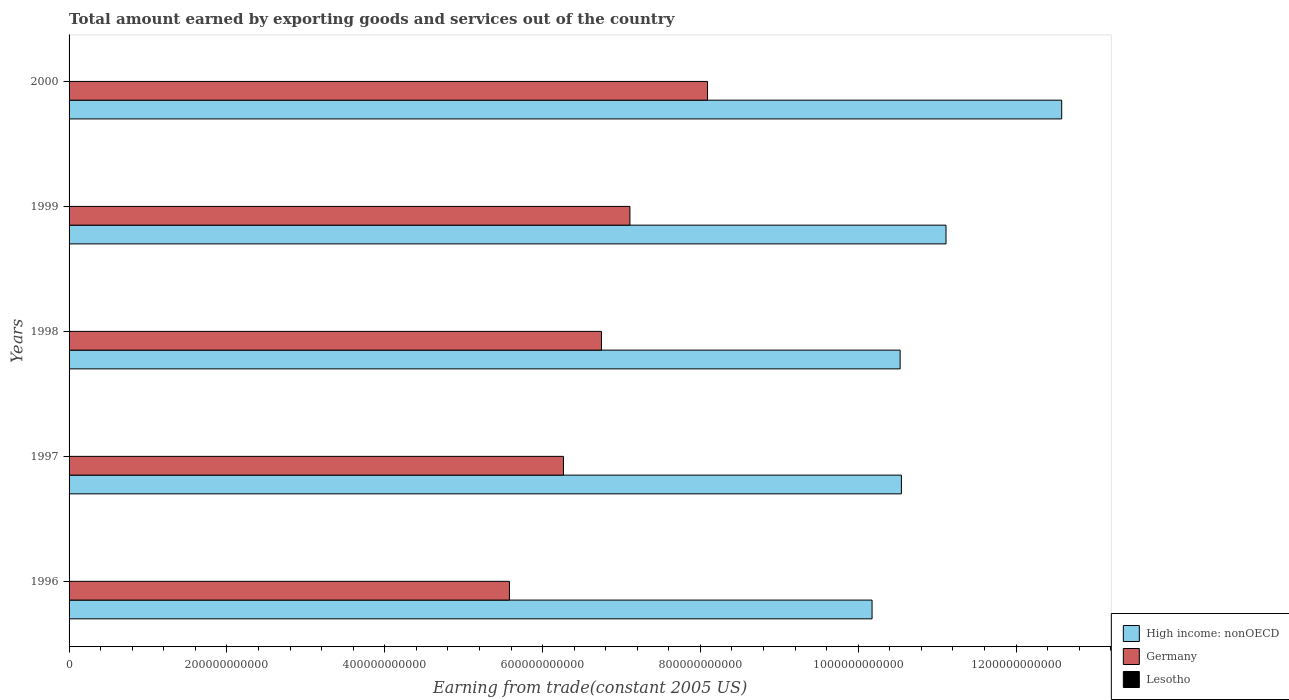How many different coloured bars are there?
Your answer should be compact. 3. How many groups of bars are there?
Offer a very short reply. 5. Are the number of bars per tick equal to the number of legend labels?
Make the answer very short. Yes. Are the number of bars on each tick of the Y-axis equal?
Your answer should be compact. Yes. How many bars are there on the 4th tick from the top?
Your answer should be compact. 3. How many bars are there on the 2nd tick from the bottom?
Your response must be concise. 3. What is the label of the 2nd group of bars from the top?
Your answer should be very brief. 1999. What is the total amount earned by exporting goods and services in High income: nonOECD in 1996?
Give a very brief answer. 1.02e+12. Across all years, what is the maximum total amount earned by exporting goods and services in High income: nonOECD?
Provide a short and direct response. 1.26e+12. Across all years, what is the minimum total amount earned by exporting goods and services in High income: nonOECD?
Ensure brevity in your answer.  1.02e+12. In which year was the total amount earned by exporting goods and services in Germany maximum?
Give a very brief answer. 2000. What is the total total amount earned by exporting goods and services in Lesotho in the graph?
Give a very brief answer. 1.39e+09. What is the difference between the total amount earned by exporting goods and services in High income: nonOECD in 1997 and that in 2000?
Keep it short and to the point. -2.03e+11. What is the difference between the total amount earned by exporting goods and services in Germany in 1997 and the total amount earned by exporting goods and services in Lesotho in 1999?
Offer a terse response. 6.26e+11. What is the average total amount earned by exporting goods and services in Germany per year?
Provide a succinct answer. 6.76e+11. In the year 1997, what is the difference between the total amount earned by exporting goods and services in High income: nonOECD and total amount earned by exporting goods and services in Germany?
Provide a short and direct response. 4.28e+11. What is the ratio of the total amount earned by exporting goods and services in Lesotho in 1996 to that in 2000?
Provide a short and direct response. 0.79. Is the difference between the total amount earned by exporting goods and services in High income: nonOECD in 1998 and 1999 greater than the difference between the total amount earned by exporting goods and services in Germany in 1998 and 1999?
Make the answer very short. No. What is the difference between the highest and the second highest total amount earned by exporting goods and services in High income: nonOECD?
Keep it short and to the point. 1.47e+11. What is the difference between the highest and the lowest total amount earned by exporting goods and services in Germany?
Ensure brevity in your answer.  2.51e+11. Is the sum of the total amount earned by exporting goods and services in Germany in 1998 and 2000 greater than the maximum total amount earned by exporting goods and services in High income: nonOECD across all years?
Keep it short and to the point. Yes. What does the 3rd bar from the top in 1997 represents?
Make the answer very short. High income: nonOECD. What does the 3rd bar from the bottom in 2000 represents?
Offer a very short reply. Lesotho. How many years are there in the graph?
Your response must be concise. 5. What is the difference between two consecutive major ticks on the X-axis?
Offer a terse response. 2.00e+11. Are the values on the major ticks of X-axis written in scientific E-notation?
Your answer should be compact. No. Does the graph contain any zero values?
Your answer should be compact. No. Where does the legend appear in the graph?
Your answer should be compact. Bottom right. How are the legend labels stacked?
Your response must be concise. Vertical. What is the title of the graph?
Offer a very short reply. Total amount earned by exporting goods and services out of the country. Does "Tajikistan" appear as one of the legend labels in the graph?
Your response must be concise. No. What is the label or title of the X-axis?
Provide a short and direct response. Earning from trade(constant 2005 US). What is the label or title of the Y-axis?
Offer a terse response. Years. What is the Earning from trade(constant 2005 US) of High income: nonOECD in 1996?
Offer a terse response. 1.02e+12. What is the Earning from trade(constant 2005 US) of Germany in 1996?
Provide a short and direct response. 5.58e+11. What is the Earning from trade(constant 2005 US) in Lesotho in 1996?
Your answer should be compact. 2.52e+08. What is the Earning from trade(constant 2005 US) in High income: nonOECD in 1997?
Offer a very short reply. 1.05e+12. What is the Earning from trade(constant 2005 US) of Germany in 1997?
Your response must be concise. 6.26e+11. What is the Earning from trade(constant 2005 US) of Lesotho in 1997?
Your answer should be very brief. 2.59e+08. What is the Earning from trade(constant 2005 US) of High income: nonOECD in 1998?
Your answer should be very brief. 1.05e+12. What is the Earning from trade(constant 2005 US) in Germany in 1998?
Keep it short and to the point. 6.75e+11. What is the Earning from trade(constant 2005 US) of Lesotho in 1998?
Provide a succinct answer. 3.01e+08. What is the Earning from trade(constant 2005 US) of High income: nonOECD in 1999?
Your response must be concise. 1.11e+12. What is the Earning from trade(constant 2005 US) in Germany in 1999?
Keep it short and to the point. 7.11e+11. What is the Earning from trade(constant 2005 US) in Lesotho in 1999?
Offer a very short reply. 2.60e+08. What is the Earning from trade(constant 2005 US) of High income: nonOECD in 2000?
Provide a succinct answer. 1.26e+12. What is the Earning from trade(constant 2005 US) of Germany in 2000?
Provide a succinct answer. 8.09e+11. What is the Earning from trade(constant 2005 US) of Lesotho in 2000?
Your response must be concise. 3.18e+08. Across all years, what is the maximum Earning from trade(constant 2005 US) in High income: nonOECD?
Your answer should be very brief. 1.26e+12. Across all years, what is the maximum Earning from trade(constant 2005 US) in Germany?
Your response must be concise. 8.09e+11. Across all years, what is the maximum Earning from trade(constant 2005 US) of Lesotho?
Offer a very short reply. 3.18e+08. Across all years, what is the minimum Earning from trade(constant 2005 US) of High income: nonOECD?
Your answer should be compact. 1.02e+12. Across all years, what is the minimum Earning from trade(constant 2005 US) of Germany?
Provide a short and direct response. 5.58e+11. Across all years, what is the minimum Earning from trade(constant 2005 US) of Lesotho?
Your answer should be very brief. 2.52e+08. What is the total Earning from trade(constant 2005 US) of High income: nonOECD in the graph?
Your answer should be very brief. 5.49e+12. What is the total Earning from trade(constant 2005 US) of Germany in the graph?
Offer a terse response. 3.38e+12. What is the total Earning from trade(constant 2005 US) in Lesotho in the graph?
Make the answer very short. 1.39e+09. What is the difference between the Earning from trade(constant 2005 US) in High income: nonOECD in 1996 and that in 1997?
Provide a short and direct response. -3.72e+1. What is the difference between the Earning from trade(constant 2005 US) in Germany in 1996 and that in 1997?
Keep it short and to the point. -6.85e+1. What is the difference between the Earning from trade(constant 2005 US) in Lesotho in 1996 and that in 1997?
Your answer should be very brief. -6.82e+06. What is the difference between the Earning from trade(constant 2005 US) in High income: nonOECD in 1996 and that in 1998?
Offer a very short reply. -3.56e+1. What is the difference between the Earning from trade(constant 2005 US) in Germany in 1996 and that in 1998?
Your answer should be compact. -1.17e+11. What is the difference between the Earning from trade(constant 2005 US) of Lesotho in 1996 and that in 1998?
Provide a succinct answer. -4.84e+07. What is the difference between the Earning from trade(constant 2005 US) of High income: nonOECD in 1996 and that in 1999?
Offer a very short reply. -9.37e+1. What is the difference between the Earning from trade(constant 2005 US) in Germany in 1996 and that in 1999?
Provide a short and direct response. -1.53e+11. What is the difference between the Earning from trade(constant 2005 US) of Lesotho in 1996 and that in 1999?
Keep it short and to the point. -7.43e+06. What is the difference between the Earning from trade(constant 2005 US) of High income: nonOECD in 1996 and that in 2000?
Provide a short and direct response. -2.40e+11. What is the difference between the Earning from trade(constant 2005 US) in Germany in 1996 and that in 2000?
Your answer should be very brief. -2.51e+11. What is the difference between the Earning from trade(constant 2005 US) of Lesotho in 1996 and that in 2000?
Provide a succinct answer. -6.55e+07. What is the difference between the Earning from trade(constant 2005 US) of High income: nonOECD in 1997 and that in 1998?
Keep it short and to the point. 1.61e+09. What is the difference between the Earning from trade(constant 2005 US) in Germany in 1997 and that in 1998?
Offer a terse response. -4.82e+1. What is the difference between the Earning from trade(constant 2005 US) of Lesotho in 1997 and that in 1998?
Make the answer very short. -4.16e+07. What is the difference between the Earning from trade(constant 2005 US) in High income: nonOECD in 1997 and that in 1999?
Provide a short and direct response. -5.65e+1. What is the difference between the Earning from trade(constant 2005 US) of Germany in 1997 and that in 1999?
Offer a terse response. -8.42e+1. What is the difference between the Earning from trade(constant 2005 US) of Lesotho in 1997 and that in 1999?
Ensure brevity in your answer.  -6.07e+05. What is the difference between the Earning from trade(constant 2005 US) of High income: nonOECD in 1997 and that in 2000?
Keep it short and to the point. -2.03e+11. What is the difference between the Earning from trade(constant 2005 US) of Germany in 1997 and that in 2000?
Your response must be concise. -1.83e+11. What is the difference between the Earning from trade(constant 2005 US) in Lesotho in 1997 and that in 2000?
Ensure brevity in your answer.  -5.87e+07. What is the difference between the Earning from trade(constant 2005 US) in High income: nonOECD in 1998 and that in 1999?
Offer a terse response. -5.81e+1. What is the difference between the Earning from trade(constant 2005 US) of Germany in 1998 and that in 1999?
Ensure brevity in your answer.  -3.61e+1. What is the difference between the Earning from trade(constant 2005 US) in Lesotho in 1998 and that in 1999?
Make the answer very short. 4.09e+07. What is the difference between the Earning from trade(constant 2005 US) of High income: nonOECD in 1998 and that in 2000?
Provide a short and direct response. -2.05e+11. What is the difference between the Earning from trade(constant 2005 US) of Germany in 1998 and that in 2000?
Offer a very short reply. -1.34e+11. What is the difference between the Earning from trade(constant 2005 US) of Lesotho in 1998 and that in 2000?
Offer a terse response. -1.72e+07. What is the difference between the Earning from trade(constant 2005 US) of High income: nonOECD in 1999 and that in 2000?
Offer a terse response. -1.47e+11. What is the difference between the Earning from trade(constant 2005 US) of Germany in 1999 and that in 2000?
Your answer should be very brief. -9.83e+1. What is the difference between the Earning from trade(constant 2005 US) in Lesotho in 1999 and that in 2000?
Provide a succinct answer. -5.81e+07. What is the difference between the Earning from trade(constant 2005 US) in High income: nonOECD in 1996 and the Earning from trade(constant 2005 US) in Germany in 1997?
Your answer should be compact. 3.91e+11. What is the difference between the Earning from trade(constant 2005 US) of High income: nonOECD in 1996 and the Earning from trade(constant 2005 US) of Lesotho in 1997?
Offer a terse response. 1.02e+12. What is the difference between the Earning from trade(constant 2005 US) of Germany in 1996 and the Earning from trade(constant 2005 US) of Lesotho in 1997?
Ensure brevity in your answer.  5.58e+11. What is the difference between the Earning from trade(constant 2005 US) of High income: nonOECD in 1996 and the Earning from trade(constant 2005 US) of Germany in 1998?
Keep it short and to the point. 3.43e+11. What is the difference between the Earning from trade(constant 2005 US) of High income: nonOECD in 1996 and the Earning from trade(constant 2005 US) of Lesotho in 1998?
Your answer should be very brief. 1.02e+12. What is the difference between the Earning from trade(constant 2005 US) in Germany in 1996 and the Earning from trade(constant 2005 US) in Lesotho in 1998?
Provide a short and direct response. 5.58e+11. What is the difference between the Earning from trade(constant 2005 US) of High income: nonOECD in 1996 and the Earning from trade(constant 2005 US) of Germany in 1999?
Offer a terse response. 3.07e+11. What is the difference between the Earning from trade(constant 2005 US) in High income: nonOECD in 1996 and the Earning from trade(constant 2005 US) in Lesotho in 1999?
Give a very brief answer. 1.02e+12. What is the difference between the Earning from trade(constant 2005 US) of Germany in 1996 and the Earning from trade(constant 2005 US) of Lesotho in 1999?
Provide a succinct answer. 5.58e+11. What is the difference between the Earning from trade(constant 2005 US) of High income: nonOECD in 1996 and the Earning from trade(constant 2005 US) of Germany in 2000?
Provide a short and direct response. 2.08e+11. What is the difference between the Earning from trade(constant 2005 US) of High income: nonOECD in 1996 and the Earning from trade(constant 2005 US) of Lesotho in 2000?
Your response must be concise. 1.02e+12. What is the difference between the Earning from trade(constant 2005 US) of Germany in 1996 and the Earning from trade(constant 2005 US) of Lesotho in 2000?
Your answer should be compact. 5.58e+11. What is the difference between the Earning from trade(constant 2005 US) in High income: nonOECD in 1997 and the Earning from trade(constant 2005 US) in Germany in 1998?
Offer a terse response. 3.80e+11. What is the difference between the Earning from trade(constant 2005 US) of High income: nonOECD in 1997 and the Earning from trade(constant 2005 US) of Lesotho in 1998?
Make the answer very short. 1.05e+12. What is the difference between the Earning from trade(constant 2005 US) of Germany in 1997 and the Earning from trade(constant 2005 US) of Lesotho in 1998?
Provide a short and direct response. 6.26e+11. What is the difference between the Earning from trade(constant 2005 US) of High income: nonOECD in 1997 and the Earning from trade(constant 2005 US) of Germany in 1999?
Make the answer very short. 3.44e+11. What is the difference between the Earning from trade(constant 2005 US) of High income: nonOECD in 1997 and the Earning from trade(constant 2005 US) of Lesotho in 1999?
Provide a short and direct response. 1.05e+12. What is the difference between the Earning from trade(constant 2005 US) of Germany in 1997 and the Earning from trade(constant 2005 US) of Lesotho in 1999?
Your response must be concise. 6.26e+11. What is the difference between the Earning from trade(constant 2005 US) of High income: nonOECD in 1997 and the Earning from trade(constant 2005 US) of Germany in 2000?
Ensure brevity in your answer.  2.46e+11. What is the difference between the Earning from trade(constant 2005 US) in High income: nonOECD in 1997 and the Earning from trade(constant 2005 US) in Lesotho in 2000?
Provide a short and direct response. 1.05e+12. What is the difference between the Earning from trade(constant 2005 US) in Germany in 1997 and the Earning from trade(constant 2005 US) in Lesotho in 2000?
Keep it short and to the point. 6.26e+11. What is the difference between the Earning from trade(constant 2005 US) in High income: nonOECD in 1998 and the Earning from trade(constant 2005 US) in Germany in 1999?
Your answer should be compact. 3.42e+11. What is the difference between the Earning from trade(constant 2005 US) in High income: nonOECD in 1998 and the Earning from trade(constant 2005 US) in Lesotho in 1999?
Make the answer very short. 1.05e+12. What is the difference between the Earning from trade(constant 2005 US) in Germany in 1998 and the Earning from trade(constant 2005 US) in Lesotho in 1999?
Provide a short and direct response. 6.74e+11. What is the difference between the Earning from trade(constant 2005 US) of High income: nonOECD in 1998 and the Earning from trade(constant 2005 US) of Germany in 2000?
Your answer should be very brief. 2.44e+11. What is the difference between the Earning from trade(constant 2005 US) of High income: nonOECD in 1998 and the Earning from trade(constant 2005 US) of Lesotho in 2000?
Your answer should be very brief. 1.05e+12. What is the difference between the Earning from trade(constant 2005 US) in Germany in 1998 and the Earning from trade(constant 2005 US) in Lesotho in 2000?
Offer a very short reply. 6.74e+11. What is the difference between the Earning from trade(constant 2005 US) in High income: nonOECD in 1999 and the Earning from trade(constant 2005 US) in Germany in 2000?
Make the answer very short. 3.02e+11. What is the difference between the Earning from trade(constant 2005 US) in High income: nonOECD in 1999 and the Earning from trade(constant 2005 US) in Lesotho in 2000?
Your answer should be very brief. 1.11e+12. What is the difference between the Earning from trade(constant 2005 US) of Germany in 1999 and the Earning from trade(constant 2005 US) of Lesotho in 2000?
Make the answer very short. 7.10e+11. What is the average Earning from trade(constant 2005 US) in High income: nonOECD per year?
Make the answer very short. 1.10e+12. What is the average Earning from trade(constant 2005 US) of Germany per year?
Your answer should be compact. 6.76e+11. What is the average Earning from trade(constant 2005 US) in Lesotho per year?
Make the answer very short. 2.78e+08. In the year 1996, what is the difference between the Earning from trade(constant 2005 US) in High income: nonOECD and Earning from trade(constant 2005 US) in Germany?
Keep it short and to the point. 4.59e+11. In the year 1996, what is the difference between the Earning from trade(constant 2005 US) in High income: nonOECD and Earning from trade(constant 2005 US) in Lesotho?
Offer a terse response. 1.02e+12. In the year 1996, what is the difference between the Earning from trade(constant 2005 US) in Germany and Earning from trade(constant 2005 US) in Lesotho?
Make the answer very short. 5.58e+11. In the year 1997, what is the difference between the Earning from trade(constant 2005 US) of High income: nonOECD and Earning from trade(constant 2005 US) of Germany?
Offer a terse response. 4.28e+11. In the year 1997, what is the difference between the Earning from trade(constant 2005 US) of High income: nonOECD and Earning from trade(constant 2005 US) of Lesotho?
Keep it short and to the point. 1.05e+12. In the year 1997, what is the difference between the Earning from trade(constant 2005 US) in Germany and Earning from trade(constant 2005 US) in Lesotho?
Your answer should be compact. 6.26e+11. In the year 1998, what is the difference between the Earning from trade(constant 2005 US) of High income: nonOECD and Earning from trade(constant 2005 US) of Germany?
Offer a very short reply. 3.78e+11. In the year 1998, what is the difference between the Earning from trade(constant 2005 US) of High income: nonOECD and Earning from trade(constant 2005 US) of Lesotho?
Keep it short and to the point. 1.05e+12. In the year 1998, what is the difference between the Earning from trade(constant 2005 US) of Germany and Earning from trade(constant 2005 US) of Lesotho?
Ensure brevity in your answer.  6.74e+11. In the year 1999, what is the difference between the Earning from trade(constant 2005 US) of High income: nonOECD and Earning from trade(constant 2005 US) of Germany?
Ensure brevity in your answer.  4.00e+11. In the year 1999, what is the difference between the Earning from trade(constant 2005 US) of High income: nonOECD and Earning from trade(constant 2005 US) of Lesotho?
Your answer should be very brief. 1.11e+12. In the year 1999, what is the difference between the Earning from trade(constant 2005 US) in Germany and Earning from trade(constant 2005 US) in Lesotho?
Offer a very short reply. 7.10e+11. In the year 2000, what is the difference between the Earning from trade(constant 2005 US) of High income: nonOECD and Earning from trade(constant 2005 US) of Germany?
Make the answer very short. 4.49e+11. In the year 2000, what is the difference between the Earning from trade(constant 2005 US) of High income: nonOECD and Earning from trade(constant 2005 US) of Lesotho?
Keep it short and to the point. 1.26e+12. In the year 2000, what is the difference between the Earning from trade(constant 2005 US) in Germany and Earning from trade(constant 2005 US) in Lesotho?
Offer a terse response. 8.09e+11. What is the ratio of the Earning from trade(constant 2005 US) in High income: nonOECD in 1996 to that in 1997?
Give a very brief answer. 0.96. What is the ratio of the Earning from trade(constant 2005 US) in Germany in 1996 to that in 1997?
Make the answer very short. 0.89. What is the ratio of the Earning from trade(constant 2005 US) in Lesotho in 1996 to that in 1997?
Offer a terse response. 0.97. What is the ratio of the Earning from trade(constant 2005 US) of High income: nonOECD in 1996 to that in 1998?
Your answer should be compact. 0.97. What is the ratio of the Earning from trade(constant 2005 US) in Germany in 1996 to that in 1998?
Offer a very short reply. 0.83. What is the ratio of the Earning from trade(constant 2005 US) of Lesotho in 1996 to that in 1998?
Give a very brief answer. 0.84. What is the ratio of the Earning from trade(constant 2005 US) of High income: nonOECD in 1996 to that in 1999?
Your answer should be compact. 0.92. What is the ratio of the Earning from trade(constant 2005 US) of Germany in 1996 to that in 1999?
Your response must be concise. 0.79. What is the ratio of the Earning from trade(constant 2005 US) of Lesotho in 1996 to that in 1999?
Your answer should be very brief. 0.97. What is the ratio of the Earning from trade(constant 2005 US) of High income: nonOECD in 1996 to that in 2000?
Provide a short and direct response. 0.81. What is the ratio of the Earning from trade(constant 2005 US) in Germany in 1996 to that in 2000?
Provide a succinct answer. 0.69. What is the ratio of the Earning from trade(constant 2005 US) in Lesotho in 1996 to that in 2000?
Your answer should be very brief. 0.79. What is the ratio of the Earning from trade(constant 2005 US) of Lesotho in 1997 to that in 1998?
Keep it short and to the point. 0.86. What is the ratio of the Earning from trade(constant 2005 US) in High income: nonOECD in 1997 to that in 1999?
Your answer should be very brief. 0.95. What is the ratio of the Earning from trade(constant 2005 US) of Germany in 1997 to that in 1999?
Provide a short and direct response. 0.88. What is the ratio of the Earning from trade(constant 2005 US) of Lesotho in 1997 to that in 1999?
Offer a terse response. 1. What is the ratio of the Earning from trade(constant 2005 US) in High income: nonOECD in 1997 to that in 2000?
Provide a succinct answer. 0.84. What is the ratio of the Earning from trade(constant 2005 US) in Germany in 1997 to that in 2000?
Your response must be concise. 0.77. What is the ratio of the Earning from trade(constant 2005 US) in Lesotho in 1997 to that in 2000?
Make the answer very short. 0.82. What is the ratio of the Earning from trade(constant 2005 US) in High income: nonOECD in 1998 to that in 1999?
Provide a succinct answer. 0.95. What is the ratio of the Earning from trade(constant 2005 US) in Germany in 1998 to that in 1999?
Your response must be concise. 0.95. What is the ratio of the Earning from trade(constant 2005 US) of Lesotho in 1998 to that in 1999?
Your answer should be compact. 1.16. What is the ratio of the Earning from trade(constant 2005 US) of High income: nonOECD in 1998 to that in 2000?
Give a very brief answer. 0.84. What is the ratio of the Earning from trade(constant 2005 US) of Germany in 1998 to that in 2000?
Give a very brief answer. 0.83. What is the ratio of the Earning from trade(constant 2005 US) in Lesotho in 1998 to that in 2000?
Provide a succinct answer. 0.95. What is the ratio of the Earning from trade(constant 2005 US) in High income: nonOECD in 1999 to that in 2000?
Offer a terse response. 0.88. What is the ratio of the Earning from trade(constant 2005 US) of Germany in 1999 to that in 2000?
Offer a very short reply. 0.88. What is the ratio of the Earning from trade(constant 2005 US) in Lesotho in 1999 to that in 2000?
Offer a very short reply. 0.82. What is the difference between the highest and the second highest Earning from trade(constant 2005 US) in High income: nonOECD?
Make the answer very short. 1.47e+11. What is the difference between the highest and the second highest Earning from trade(constant 2005 US) in Germany?
Offer a terse response. 9.83e+1. What is the difference between the highest and the second highest Earning from trade(constant 2005 US) in Lesotho?
Make the answer very short. 1.72e+07. What is the difference between the highest and the lowest Earning from trade(constant 2005 US) of High income: nonOECD?
Offer a terse response. 2.40e+11. What is the difference between the highest and the lowest Earning from trade(constant 2005 US) in Germany?
Make the answer very short. 2.51e+11. What is the difference between the highest and the lowest Earning from trade(constant 2005 US) of Lesotho?
Provide a succinct answer. 6.55e+07. 